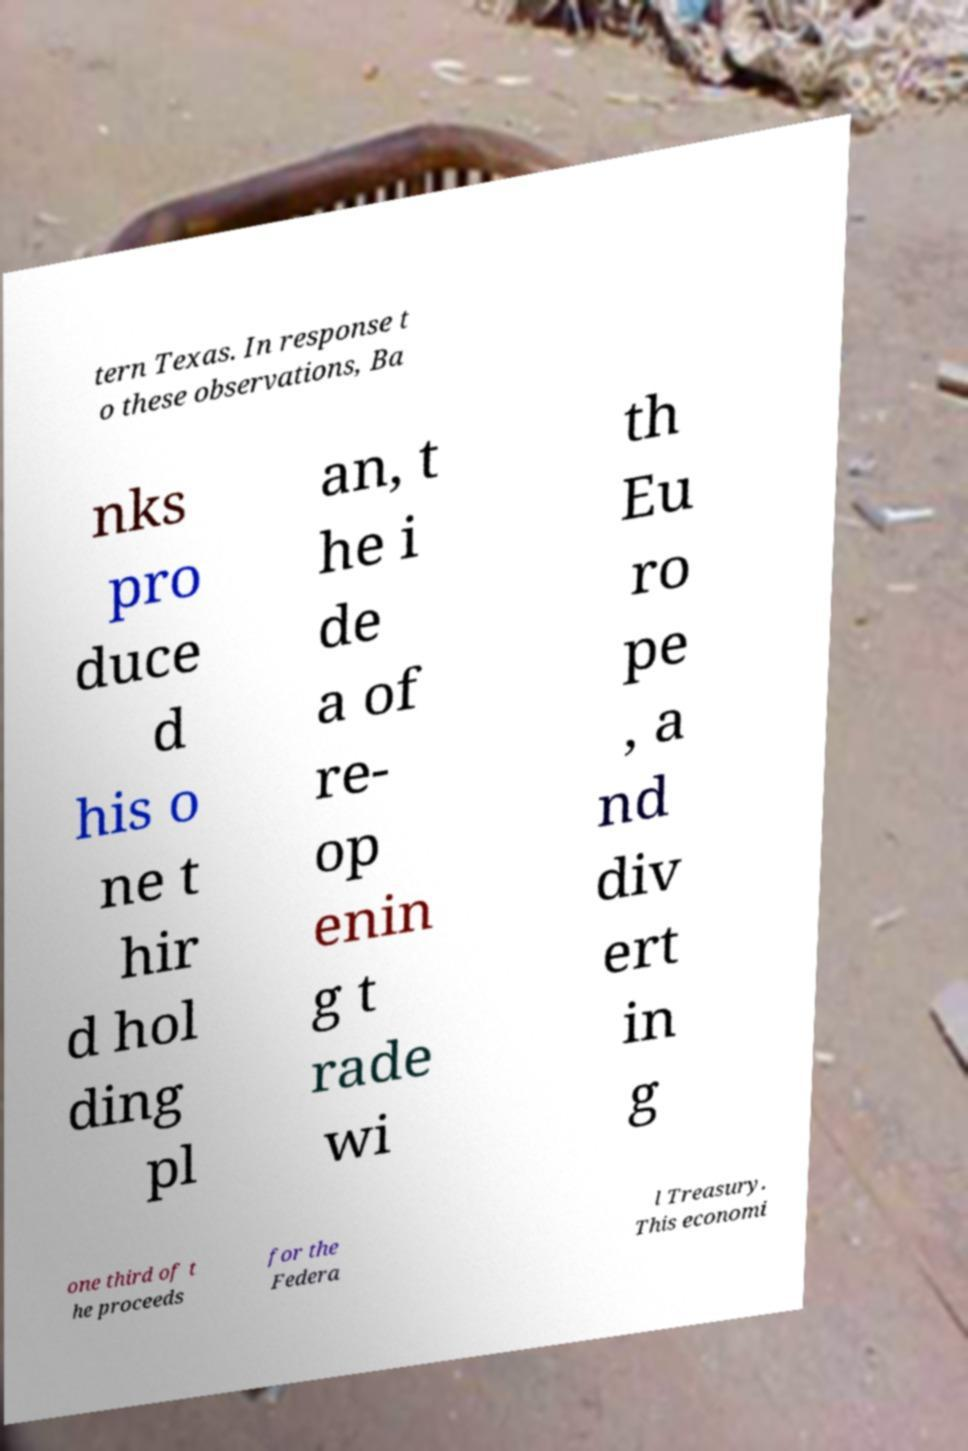Please identify and transcribe the text found in this image. tern Texas. In response t o these observations, Ba nks pro duce d his o ne t hir d hol ding pl an, t he i de a of re- op enin g t rade wi th Eu ro pe , a nd div ert in g one third of t he proceeds for the Federa l Treasury. This economi 